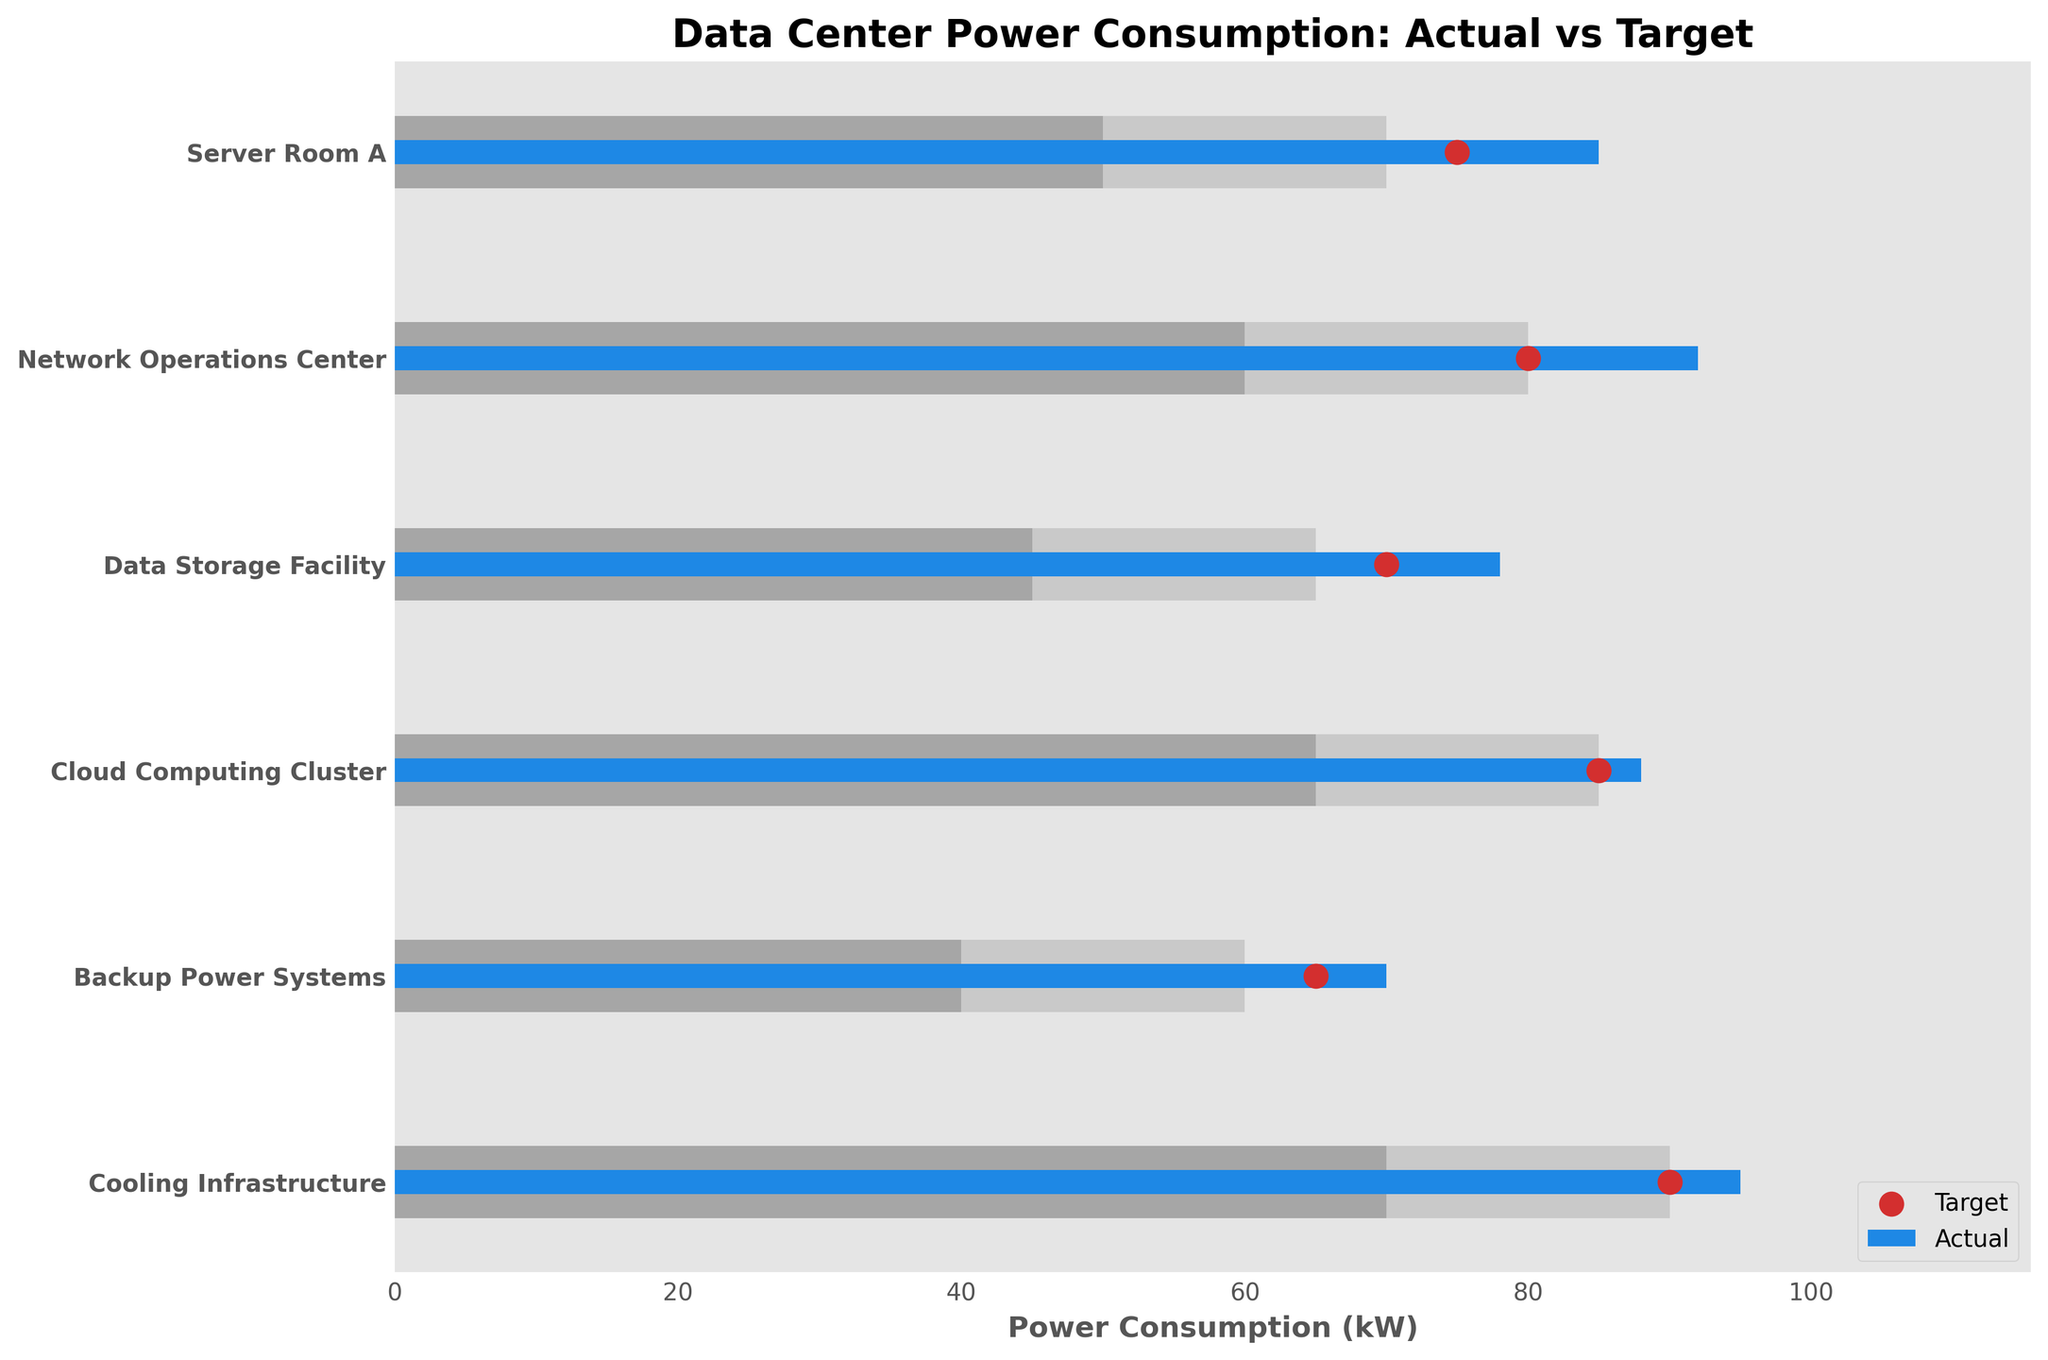What's the title of the chart? The title of the chart is usually found at the top center. It describes the content of the chart. Here, it's indicated in the code.
Answer: Data Center Power Consumption: Actual vs Target How many data center categories are displayed on the chart? Count the number of unique categories listed on the y-axis. In the provided data, there are 6 categories.
Answer: 6 What is the actual power consumption for the Network Operations Center? Locate the 'Network Operations Center' row and check the actual consumption bar length, which corresponds to the value given in the data.
Answer: 92 kW Which category has the highest target power consumption? Compare the target values for all categories and identify the maximum one. The Cooling Infrastructure has the highest target at 90 kW.
Answer: Cooling Infrastructure Is the actual power consumption for the Server Room A above or below the target? Compare the actual value (85 kW) to the target value (75 kW). Since 85 is greater than 75, it's above the target.
Answer: Above What is the difference between actual and target power consumption for the Data Storage Facility? Subtract the target value (70 kW) from the actual value (78 kW). 78 - 70 = 8 kW.
Answer: 8 kW How many categories have actual power consumption exceeding their target values? Compare actual and target values for each category and count the instances where actual > target. Server Room A, Network Operations Center, and Cooling Infrastructure exceed targets (3 categories).
Answer: 3 Which category's actual consumption is furthest from its target? Calculate the absolute differences between actual and target values for each category. The Network Operations Center has the largest difference:
Answer: Network Operations Center What color is used for the actual values in the chart? The color of the bars representing actual values is specified as blue in the code.
Answer: Blue What range of power consumption does the 'Cloud Computing Cluster' fall into? Examine the ranges (Range1, Range2, Range3) for this specific category and see where its actual consumption (88 kW) lies. It's in the range 85-105 kW.
Answer: Range3 